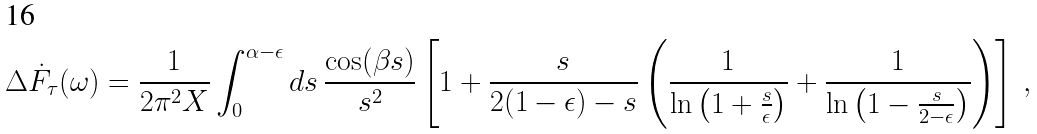<formula> <loc_0><loc_0><loc_500><loc_500>\Delta \dot { F } _ { \tau } ( \omega ) & = \frac { 1 } { 2 \pi ^ { 2 } X } \int _ { 0 } ^ { \alpha - \epsilon } d s \, \frac { \cos ( \beta s ) } { s ^ { 2 } } \left [ 1 + \frac { s } { 2 ( 1 - \epsilon ) - s } \left ( \frac { 1 } { \ln \left ( 1 + \frac { s } { \epsilon } \right ) } + \frac { 1 } { \ln \left ( 1 - \frac { s } { 2 - \epsilon } \right ) } \right ) \right ] \, ,</formula> 